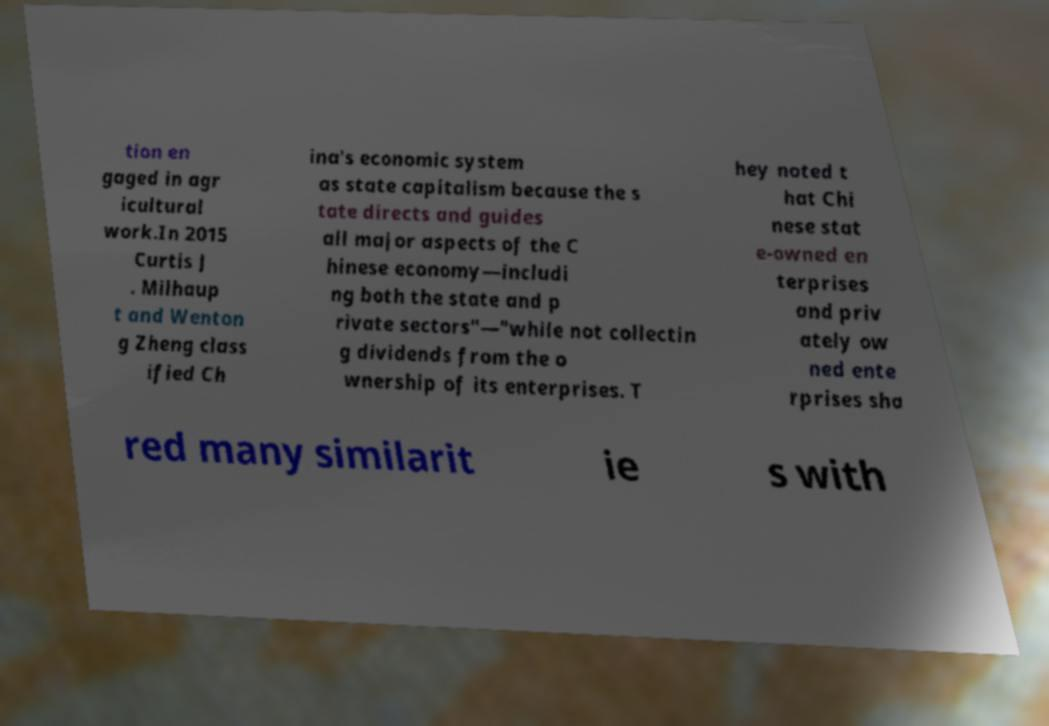What messages or text are displayed in this image? I need them in a readable, typed format. tion en gaged in agr icultural work.In 2015 Curtis J . Milhaup t and Wenton g Zheng class ified Ch ina's economic system as state capitalism because the s tate directs and guides all major aspects of the C hinese economy—includi ng both the state and p rivate sectors"—"while not collectin g dividends from the o wnership of its enterprises. T hey noted t hat Chi nese stat e-owned en terprises and priv ately ow ned ente rprises sha red many similarit ie s with 